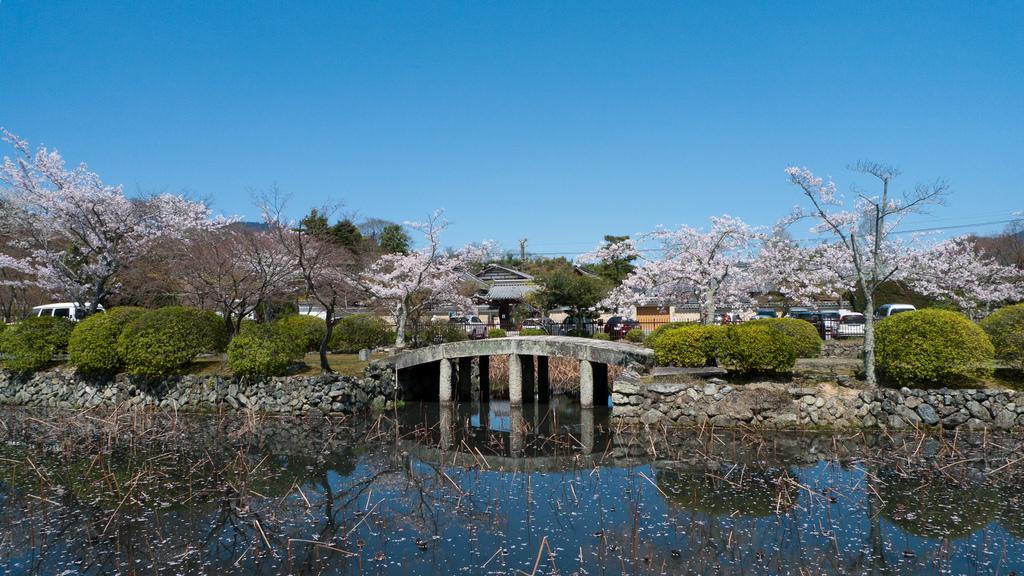Please provide a concise description of this image. In this image we can see many trees. There are many vehicles in the image. We see the reflections of the sky, a bridge and the rock wall on the water surface. There is a house in the image. There is a bridge in the image. We can see the sky in the image. 